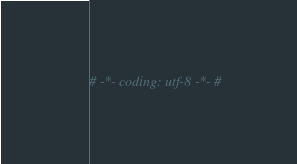Convert code to text. <code><loc_0><loc_0><loc_500><loc_500><_Python_># -*- coding: utf-8 -*- #</code> 